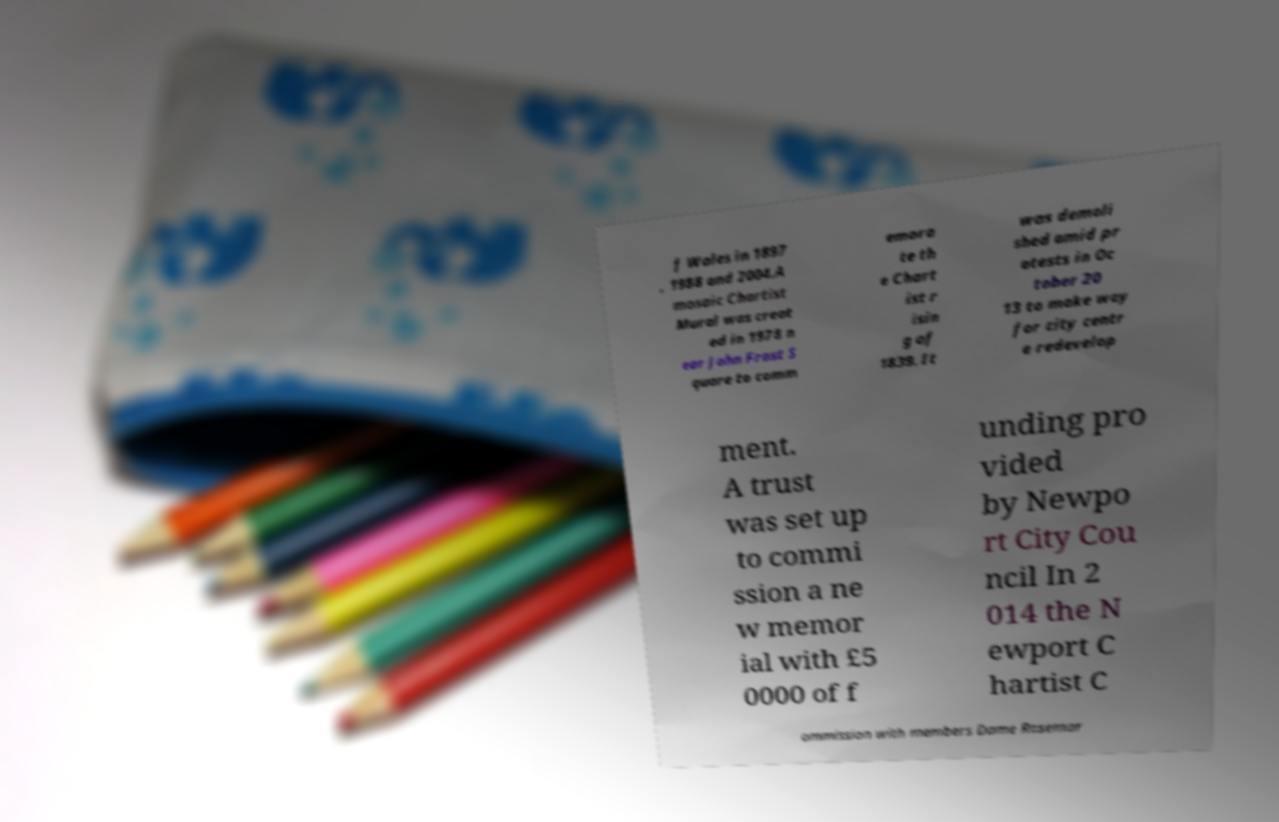Can you read and provide the text displayed in the image?This photo seems to have some interesting text. Can you extract and type it out for me? f Wales in 1897 , 1988 and 2004.A mosaic Chartist Mural was creat ed in 1978 n ear John Frost S quare to comm emora te th e Chart ist r isin g of 1839. It was demoli shed amid pr otests in Oc tober 20 13 to make way for city centr e redevelop ment. A trust was set up to commi ssion a ne w memor ial with £5 0000 of f unding pro vided by Newpo rt City Cou ncil In 2 014 the N ewport C hartist C ommission with members Dame Rosemar 